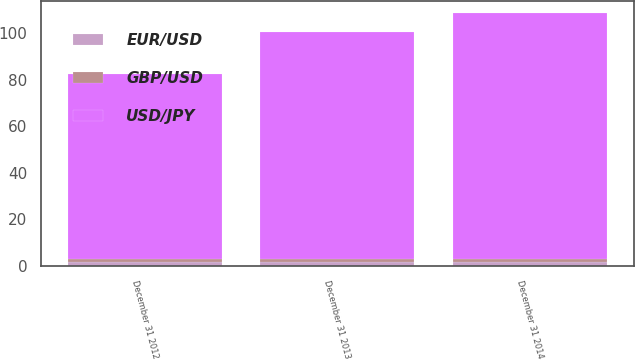<chart> <loc_0><loc_0><loc_500><loc_500><stacked_bar_chart><ecel><fcel>December 31 2012<fcel>December 31 2013<fcel>December 31 2014<nl><fcel>EUR/USD<fcel>1.58<fcel>1.56<fcel>1.65<nl><fcel>GBP/USD<fcel>1.29<fcel>1.33<fcel>1.33<nl><fcel>USD/JPY<fcel>79.79<fcel>97.46<fcel>105.59<nl></chart> 